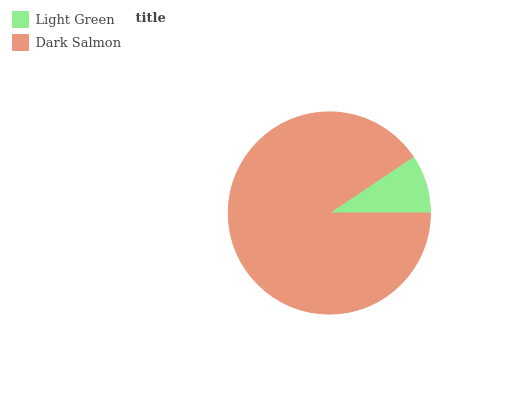Is Light Green the minimum?
Answer yes or no. Yes. Is Dark Salmon the maximum?
Answer yes or no. Yes. Is Dark Salmon the minimum?
Answer yes or no. No. Is Dark Salmon greater than Light Green?
Answer yes or no. Yes. Is Light Green less than Dark Salmon?
Answer yes or no. Yes. Is Light Green greater than Dark Salmon?
Answer yes or no. No. Is Dark Salmon less than Light Green?
Answer yes or no. No. Is Dark Salmon the high median?
Answer yes or no. Yes. Is Light Green the low median?
Answer yes or no. Yes. Is Light Green the high median?
Answer yes or no. No. Is Dark Salmon the low median?
Answer yes or no. No. 